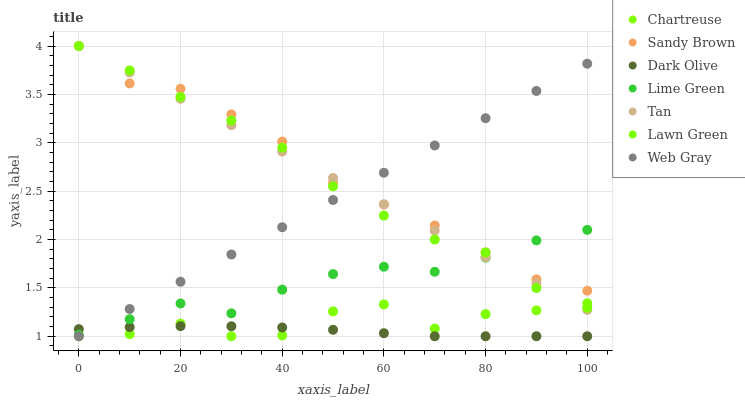Does Dark Olive have the minimum area under the curve?
Answer yes or no. Yes. Does Sandy Brown have the maximum area under the curve?
Answer yes or no. Yes. Does Web Gray have the minimum area under the curve?
Answer yes or no. No. Does Web Gray have the maximum area under the curve?
Answer yes or no. No. Is Tan the smoothest?
Answer yes or no. Yes. Is Chartreuse the roughest?
Answer yes or no. Yes. Is Web Gray the smoothest?
Answer yes or no. No. Is Web Gray the roughest?
Answer yes or no. No. Does Web Gray have the lowest value?
Answer yes or no. Yes. Does Sandy Brown have the lowest value?
Answer yes or no. No. Does Tan have the highest value?
Answer yes or no. Yes. Does Web Gray have the highest value?
Answer yes or no. No. Is Dark Olive less than Sandy Brown?
Answer yes or no. Yes. Is Lime Green greater than Chartreuse?
Answer yes or no. Yes. Does Web Gray intersect Lawn Green?
Answer yes or no. Yes. Is Web Gray less than Lawn Green?
Answer yes or no. No. Is Web Gray greater than Lawn Green?
Answer yes or no. No. Does Dark Olive intersect Sandy Brown?
Answer yes or no. No. 